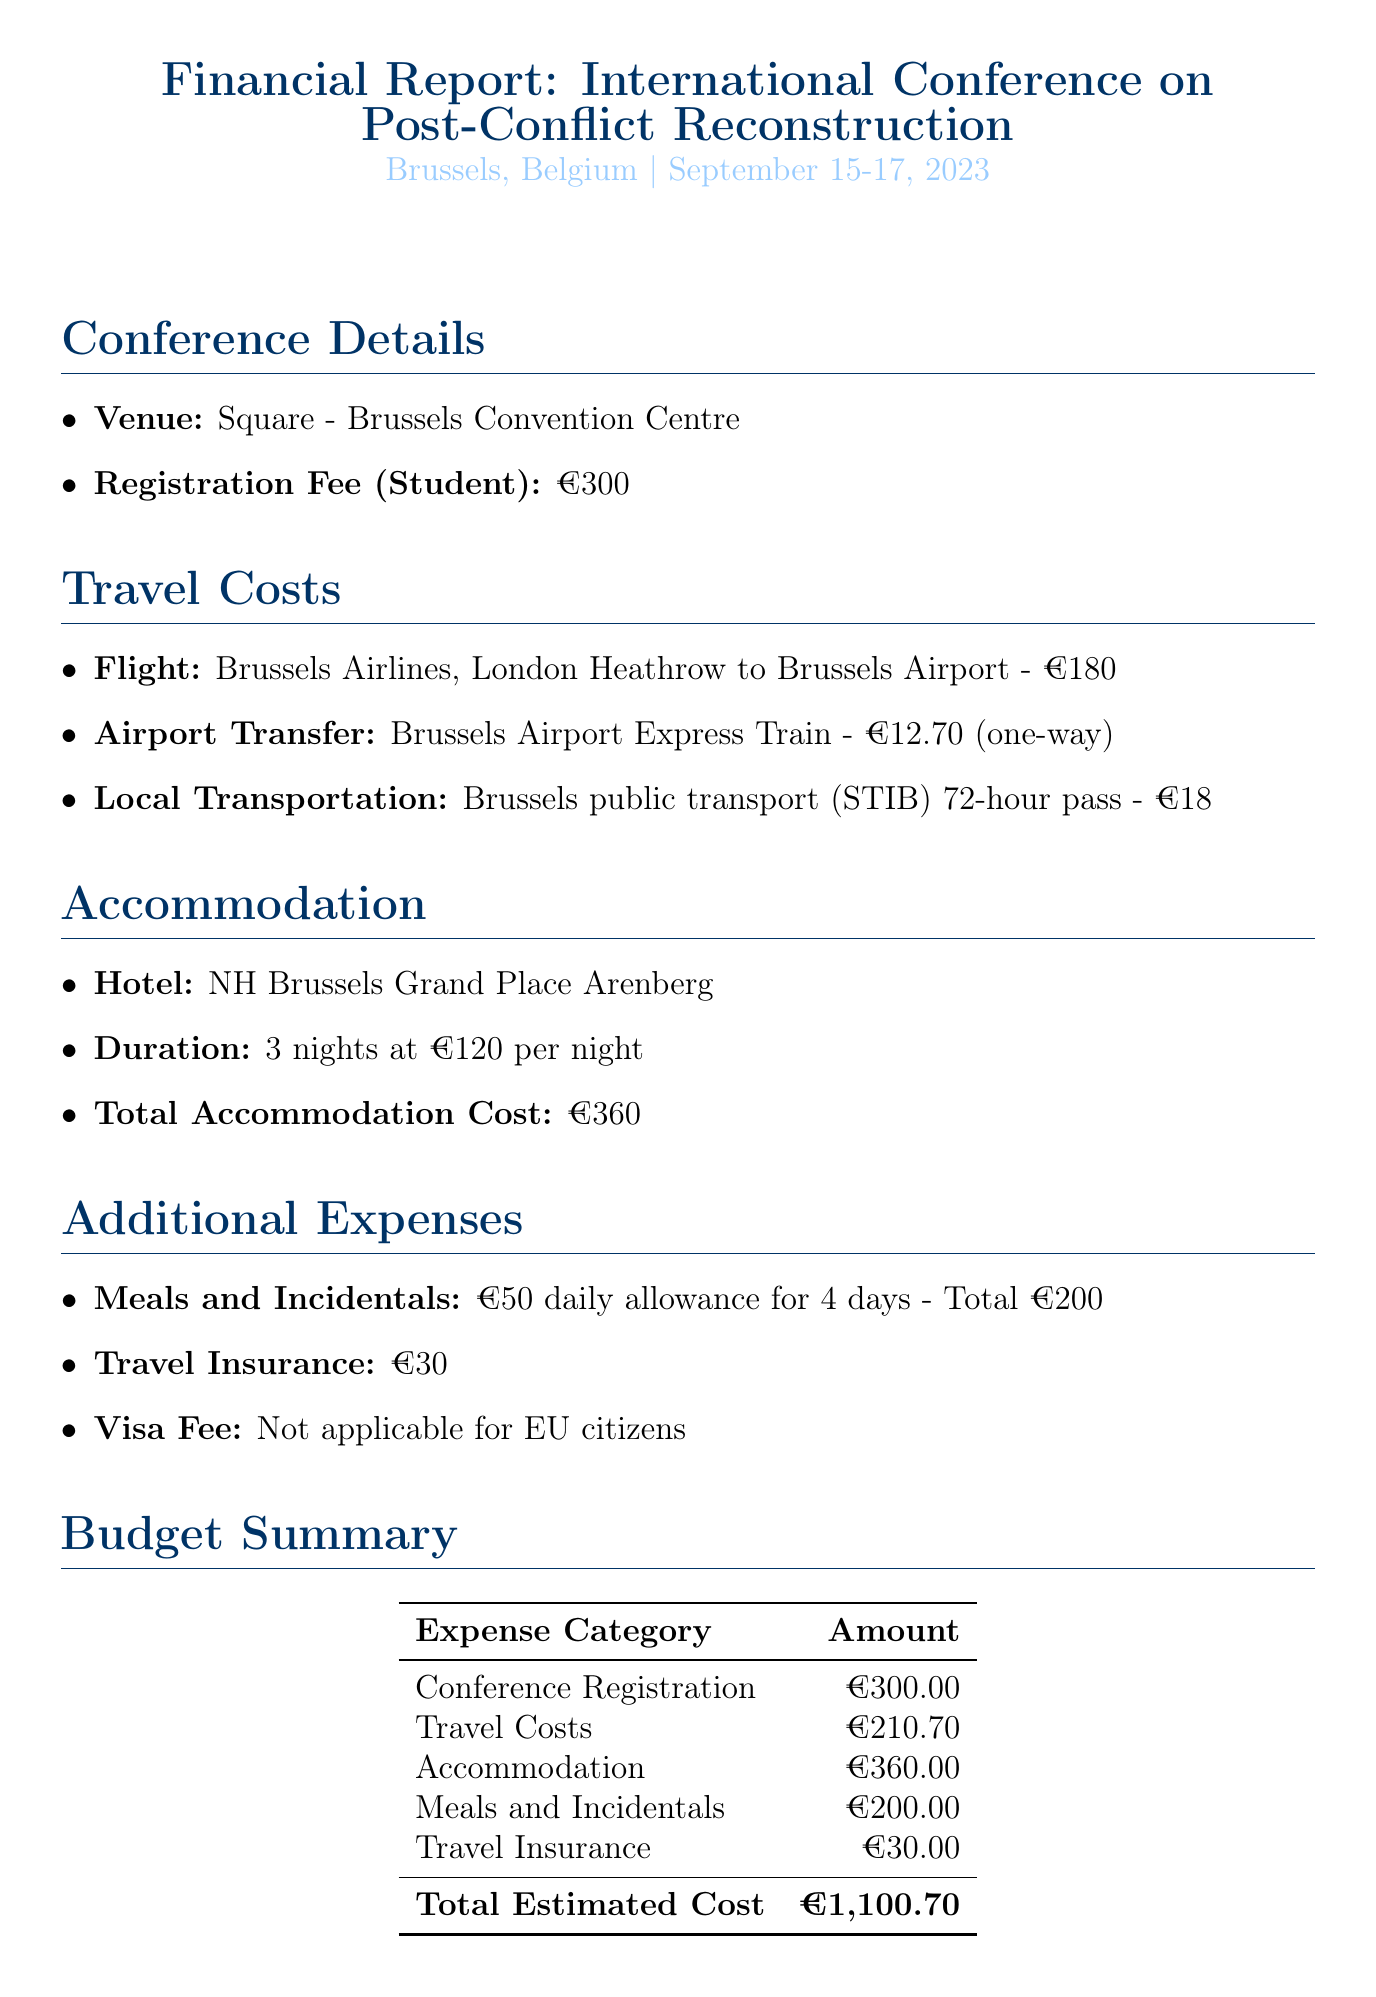What is the total estimated cost? The total estimated cost is provided in the Budget Summary section, which sums up all expenses, arriving at €1,100.70.
Answer: €1,100.70 What is the student registration fee? The registration fee for students is listed under Conference Details, specifically highlighted as €300.
Answer: €300 How many nights will the accommodation last? The accommodation duration is specified in the Accommodation section, which states it is for 3 nights.
Answer: 3 What is the method of local transportation? The method of local transportation is mentioned in the Travel Costs section where it indicates the use of the Brussels public transport (STIB) 72-hour pass.
Answer: Brussels public transport (STIB) 72-hour pass What is the cost of travel insurance? The cost of travel insurance is explicitly mentioned under Additional Expenses as €30.
Answer: €30 How much funding will come from the university grant? The university grant amount is provided under the Funding Sources section, indicating €800.
Answer: €800 What is the total cost for meals and incidentals? The meals and incidentals total is detailed in the Additional Expenses section as €200.
Answer: €200 What airline is providing the flight? The airline for the flight is noted in the Travel Costs section as Brussels Airlines.
Answer: Brussels Airlines What is the total amount of personal contribution? The personal contribution is the remaining balance after accounting for the university grant and total estimated cost. Thus, it is calculated to be €300.70.
Answer: €300.70 What mileage method is suggested for airport transfers? The suggested method for airport transfers is specifically mentioned as the Brussels Airport Express Train.
Answer: Brussels Airport Express Train 